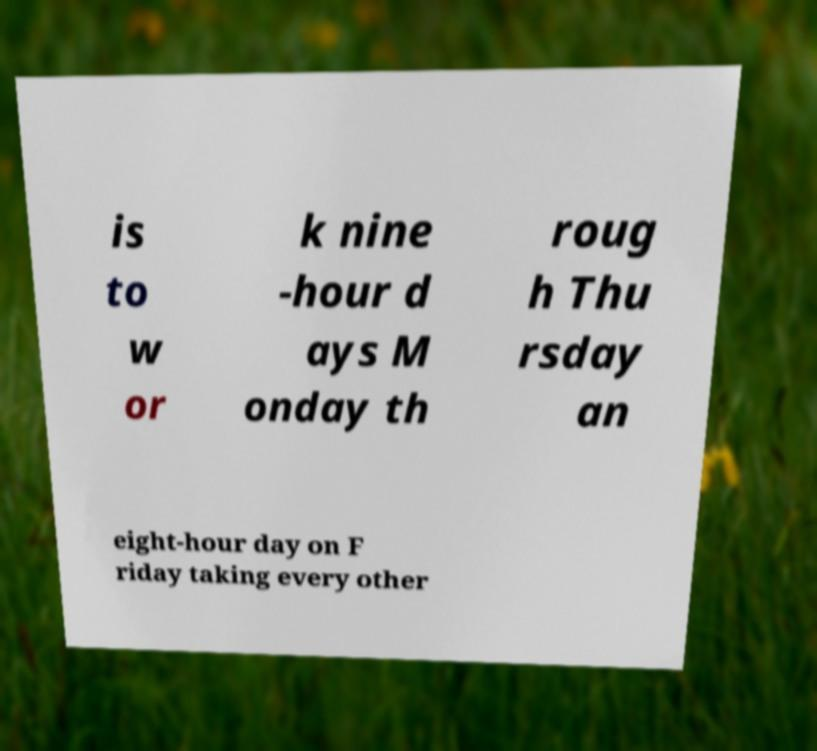Could you assist in decoding the text presented in this image and type it out clearly? is to w or k nine -hour d ays M onday th roug h Thu rsday an eight-hour day on F riday taking every other 